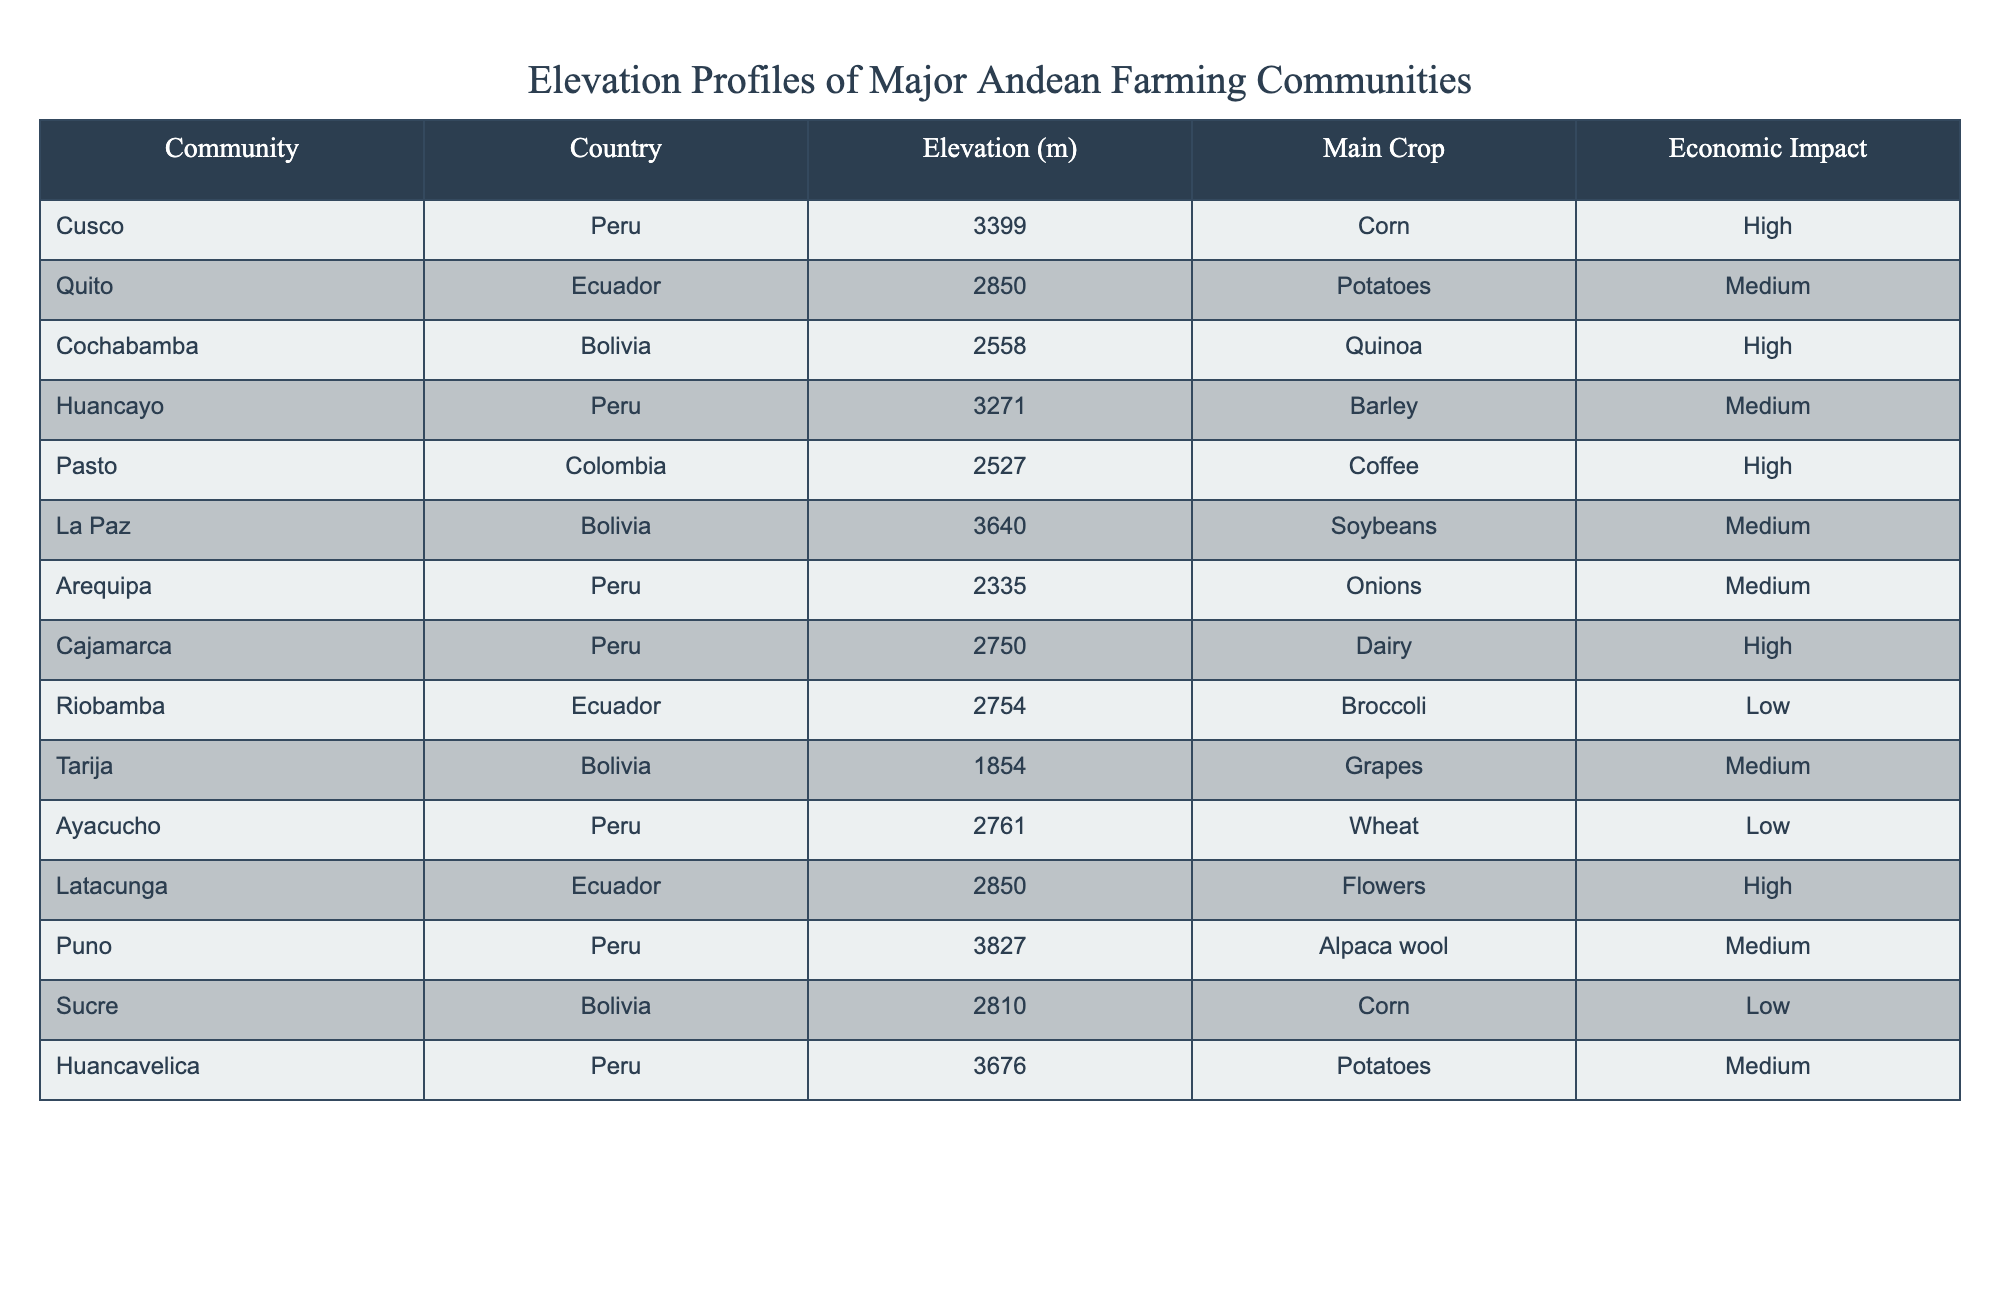What is the elevation of the community in Cusco? The table lists the elevation of Cusco as 3399 meters.
Answer: 3399 m Which community has the highest elevation? By examining the elevation values in the table, La Paz has the highest elevation at 3640 meters.
Answer: La Paz What main crop is grown in Huancayo? The table indicates that the main crop grown in Huancayo is barley.
Answer: Barley How many communities have a high economic impact? Reviewing the economic impact, there are five communities (Cusco, Cochabamba, Pasto, Cajamarca, Latacunga) listed with high economic impact.
Answer: 5 What is the average elevation of the communities listed? Summing the elevations gives 3399 + 2850 + 2558 + 3271 + 2527 + 3640 + 2335 + 2750 + 2754 + 1854 + 2761 + 2850 + 3827 + 2810 + 3676 =  37106 meters, and there are 14 communities, so the average elevation is 37106/14 = 2643.29 m.
Answer: 2643.29 m Is the economic impact of coffee low? According to the table, the economic impact of coffee in Pasto is categorized as high, not low. Therefore, the statement is false.
Answer: No Which main crop is cultivated at the highest elevation, and at what elevation? The community with the highest elevation is La Paz at 3640 meters, where soybeans are cultivated.
Answer: Soybeans at 3640 m How do the elevations correlate with the economic impact? By analyzing the table, no clear correlation can be established directly between elevation and economic impact, as both high and low economic impacts exist across different elevations.
Answer: No clear correlation What is the total economic impact of the crop types from communities above 3000 meters? Looking at the table, the communities above 3000 meters are Cusco, Huancayo, La Paz, Puno, and Huancavelica with economic impacts of High, Medium, Medium, Medium, and Medium, respectively. The total economic impact is High + Medium + Medium + Medium + Medium.
Answer: Medium (since High counts as one.) Which community produces the crop with the lowest economic impact? According to the table, the community of Riobamba has the lowest economic impact, which is categorized as low, while producing broccoli.
Answer: Riobamba 